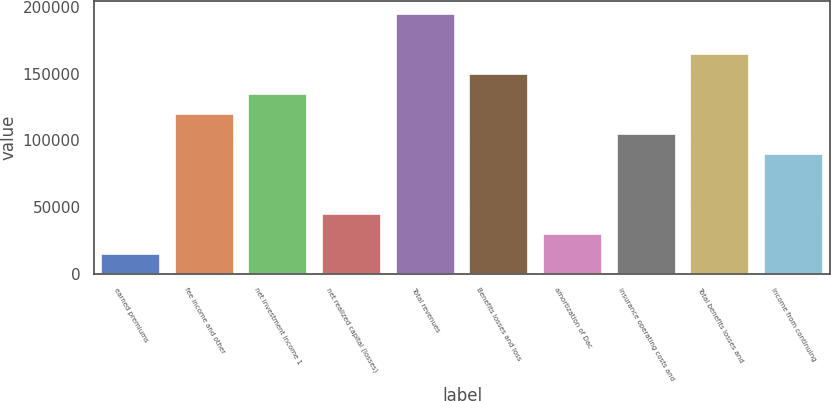<chart> <loc_0><loc_0><loc_500><loc_500><bar_chart><fcel>earned premiums<fcel>fee income and other<fcel>net investment income 1<fcel>net realized capital (losses)<fcel>Total revenues<fcel>Benefits losses and loss<fcel>amortization of Dac<fcel>insurance operating costs and<fcel>Total benefits losses and<fcel>Income from continuing<nl><fcel>15051.4<fcel>120033<fcel>135031<fcel>45046.2<fcel>195020<fcel>150028<fcel>30048.8<fcel>105036<fcel>165025<fcel>90038.4<nl></chart> 